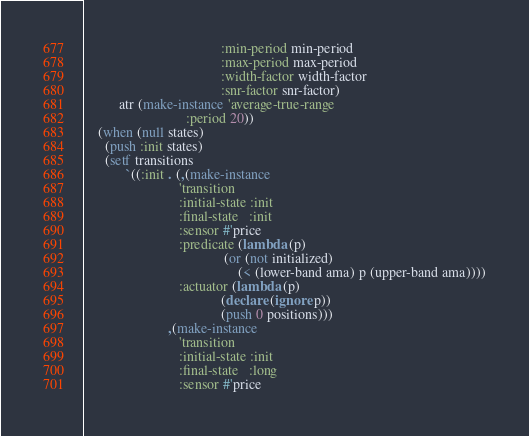<code> <loc_0><loc_0><loc_500><loc_500><_Lisp_>                                       :min-period min-period
                                       :max-period max-period
                                       :width-factor width-factor
                                       :snr-factor snr-factor)
          atr (make-instance 'average-true-range
                             :period 20))
    (when (null states)
      (push :init states)
      (setf transitions
            `((:init . (,(make-instance
                           'transition
                           :initial-state :init
                           :final-state   :init
                           :sensor #'price
                           :predicate (lambda (p)
                                        (or (not initialized)
                                            (< (lower-band ama) p (upper-band ama))))
                           :actuator (lambda (p)
                                       (declare (ignore p))
                                       (push 0 positions)))
                        ,(make-instance
                           'transition
                           :initial-state :init
                           :final-state   :long
                           :sensor #'price</code> 